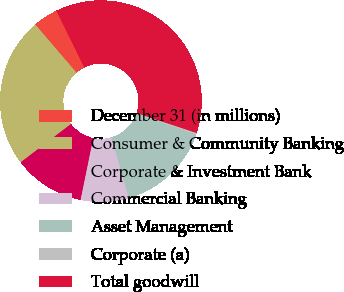Convert chart to OTSL. <chart><loc_0><loc_0><loc_500><loc_500><pie_chart><fcel>December 31 (in millions)<fcel>Consumer & Community Banking<fcel>Corporate & Investment Bank<fcel>Commercial Banking<fcel>Asset Management<fcel>Corporate (a)<fcel>Total goodwill<nl><fcel>4.0%<fcel>24.09%<fcel>11.42%<fcel>7.71%<fcel>15.12%<fcel>0.29%<fcel>37.37%<nl></chart> 